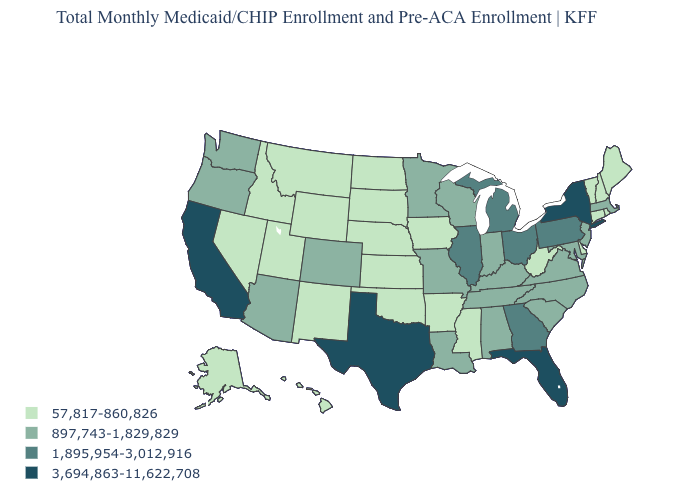Name the states that have a value in the range 1,895,954-3,012,916?
Give a very brief answer. Georgia, Illinois, Michigan, Ohio, Pennsylvania. What is the value of South Dakota?
Write a very short answer. 57,817-860,826. What is the value of Louisiana?
Write a very short answer. 897,743-1,829,829. How many symbols are there in the legend?
Answer briefly. 4. Name the states that have a value in the range 897,743-1,829,829?
Be succinct. Alabama, Arizona, Colorado, Indiana, Kentucky, Louisiana, Maryland, Massachusetts, Minnesota, Missouri, New Jersey, North Carolina, Oregon, South Carolina, Tennessee, Virginia, Washington, Wisconsin. Does Florida have the highest value in the USA?
Give a very brief answer. Yes. Does Minnesota have a lower value than Maryland?
Give a very brief answer. No. What is the highest value in states that border Virginia?
Short answer required. 897,743-1,829,829. Name the states that have a value in the range 3,694,863-11,622,708?
Be succinct. California, Florida, New York, Texas. Does Pennsylvania have the same value as Texas?
Be succinct. No. What is the value of South Dakota?
Give a very brief answer. 57,817-860,826. How many symbols are there in the legend?
Give a very brief answer. 4. Among the states that border Nevada , which have the lowest value?
Keep it brief. Idaho, Utah. What is the lowest value in the USA?
Write a very short answer. 57,817-860,826. Among the states that border Mississippi , which have the lowest value?
Short answer required. Arkansas. 